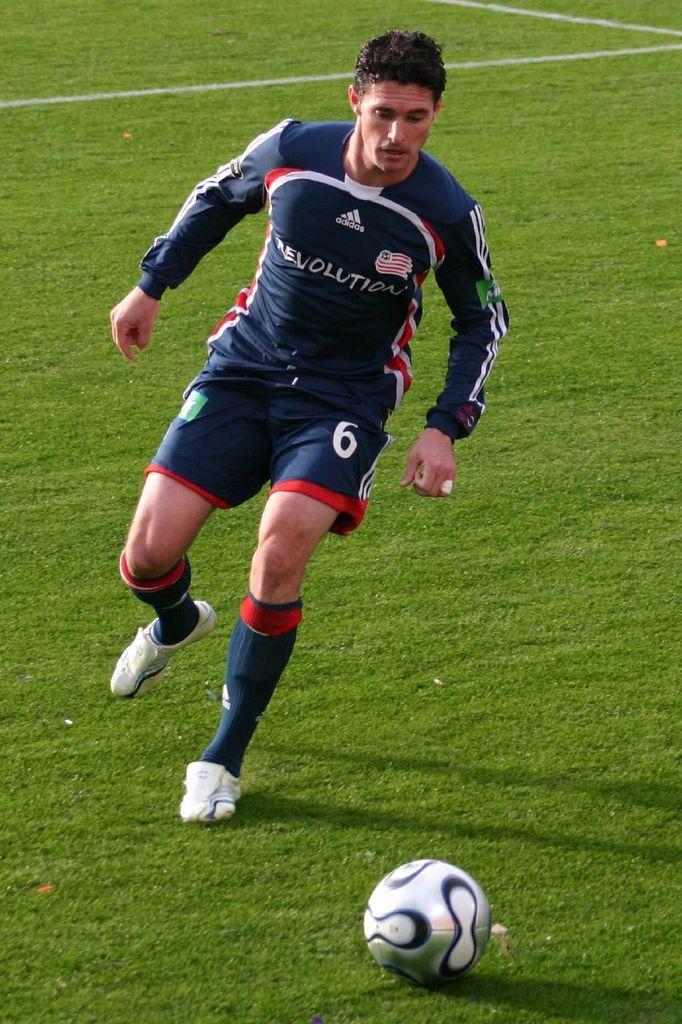Can you describe this image briefly? In this image there is a person. In front of him there is a ball. At the bottom of the image there is grass on the surface. 